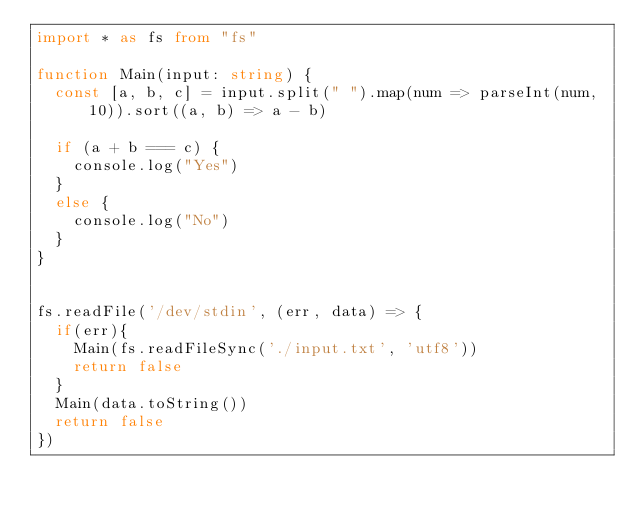<code> <loc_0><loc_0><loc_500><loc_500><_TypeScript_>import * as fs from "fs"

function Main(input: string) {
  const [a, b, c] = input.split(" ").map(num => parseInt(num, 10)).sort((a, b) => a - b)

  if (a + b === c) {
    console.log("Yes")
  }
  else {
    console.log("No")
  }
}


fs.readFile('/dev/stdin', (err, data) => {
  if(err){
    Main(fs.readFileSync('./input.txt', 'utf8'))
    return false
  }
  Main(data.toString())
  return false
})</code> 